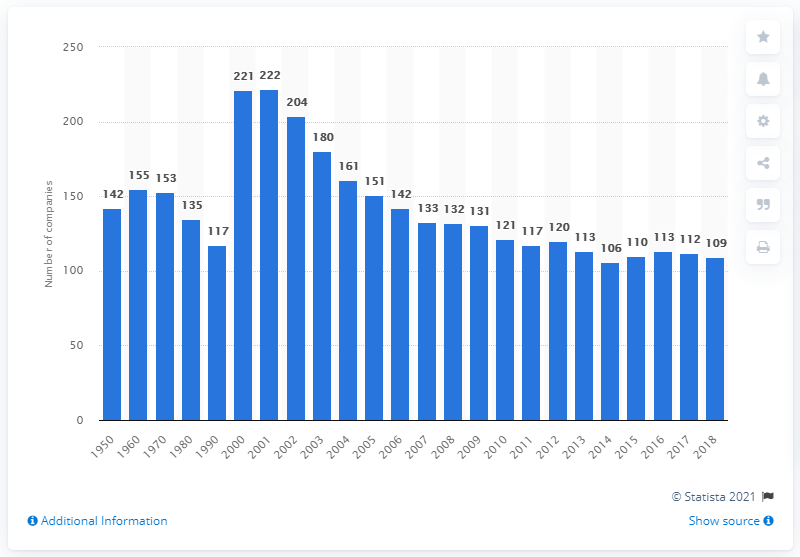Draw attention to some important aspects in this diagram. There were 109 mutual life insurance companies in the United States in 2018. 